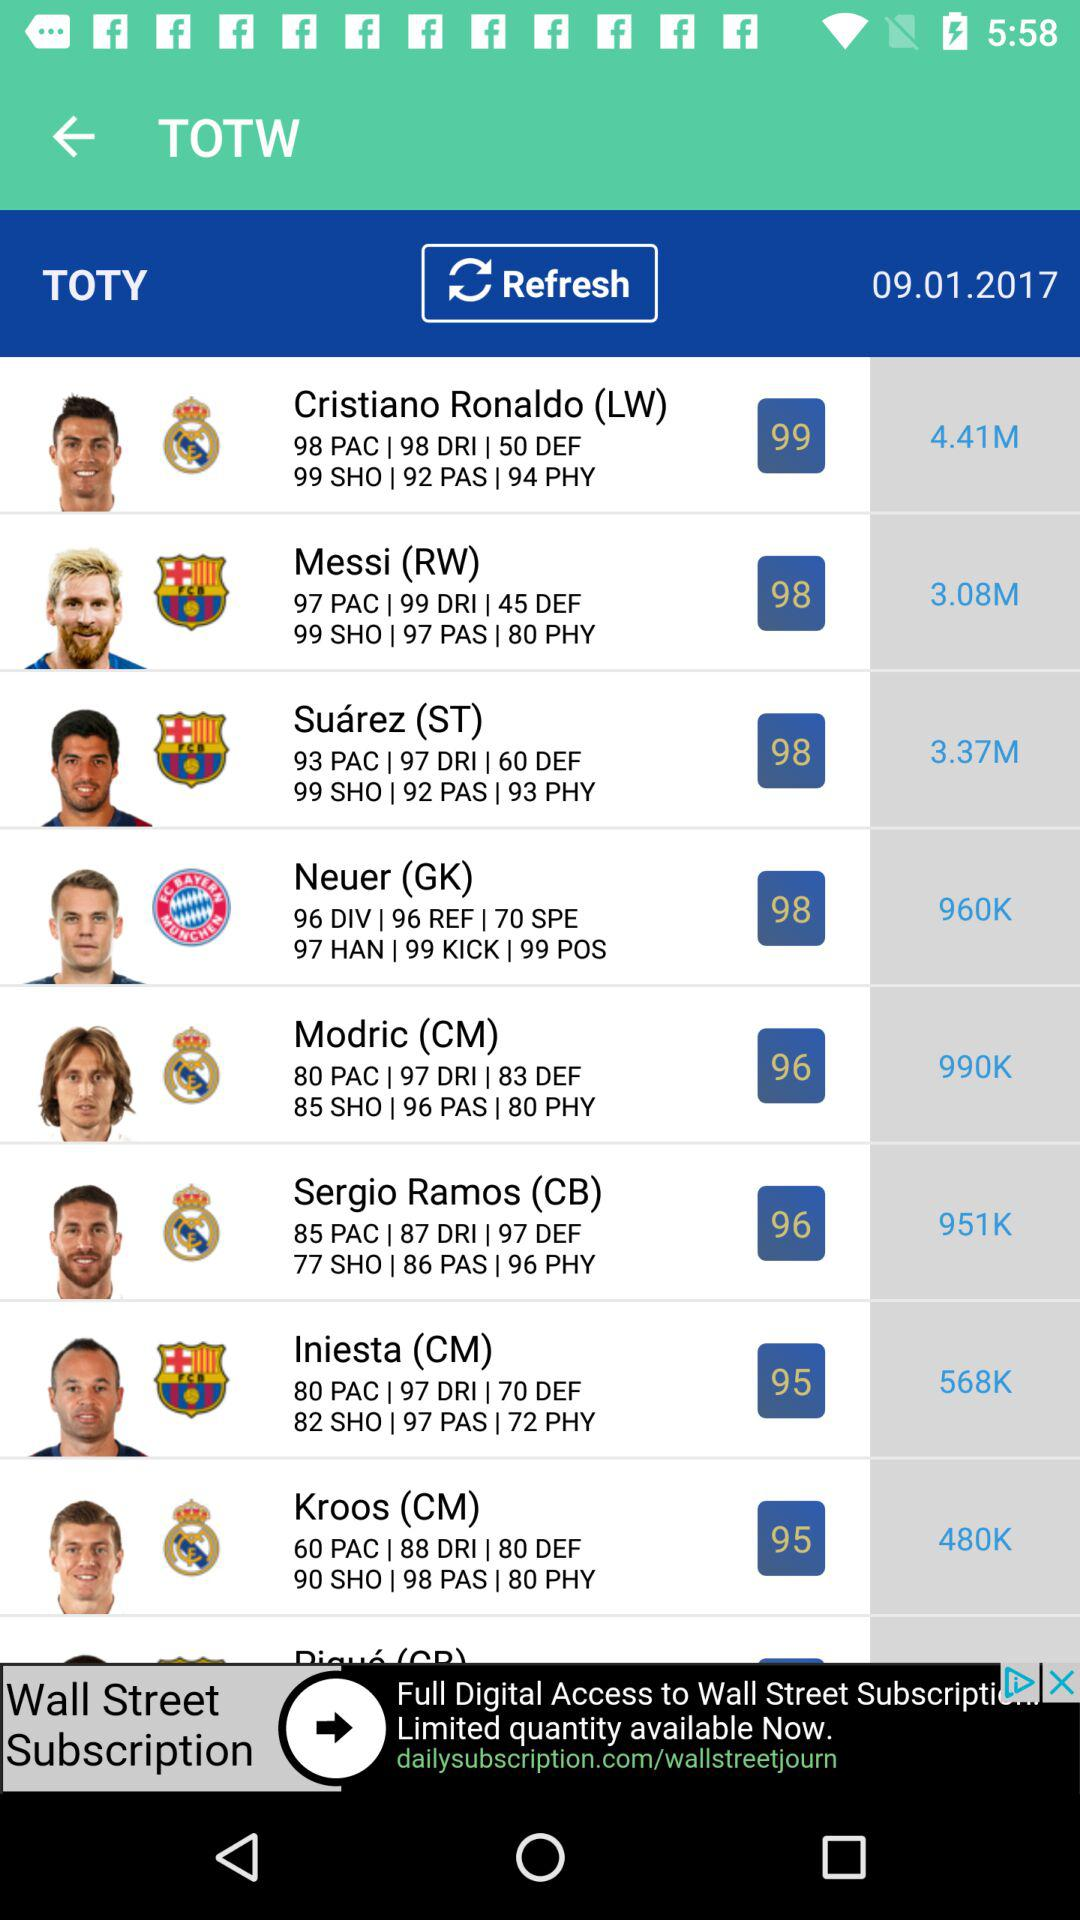Which player has 88 DRI? The player is Kroos. 